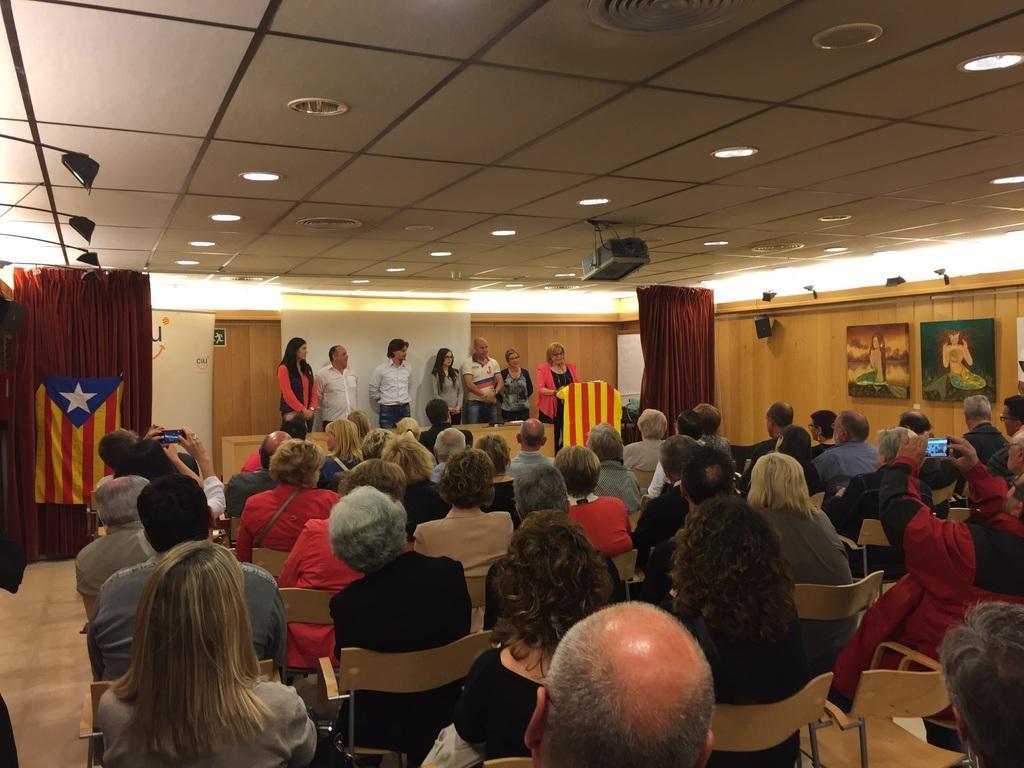How would you summarize this image in a sentence or two? In this image I can see people where few are standing and rest all are sitting on chairs. I can see two of them are holding cameras. I can also see few flags, red colour curtain, a projector machine and I can see few frames on wall. I can also see number of lights on ceiling. 